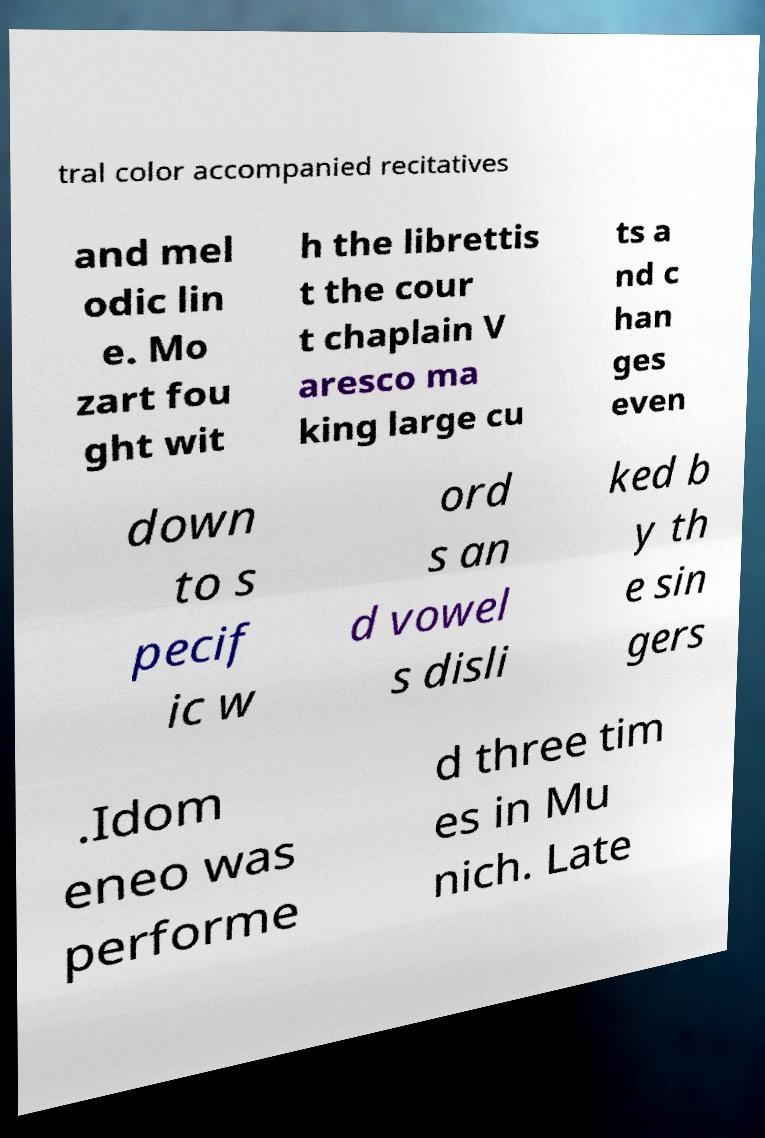Could you assist in decoding the text presented in this image and type it out clearly? tral color accompanied recitatives and mel odic lin e. Mo zart fou ght wit h the librettis t the cour t chaplain V aresco ma king large cu ts a nd c han ges even down to s pecif ic w ord s an d vowel s disli ked b y th e sin gers .Idom eneo was performe d three tim es in Mu nich. Late 